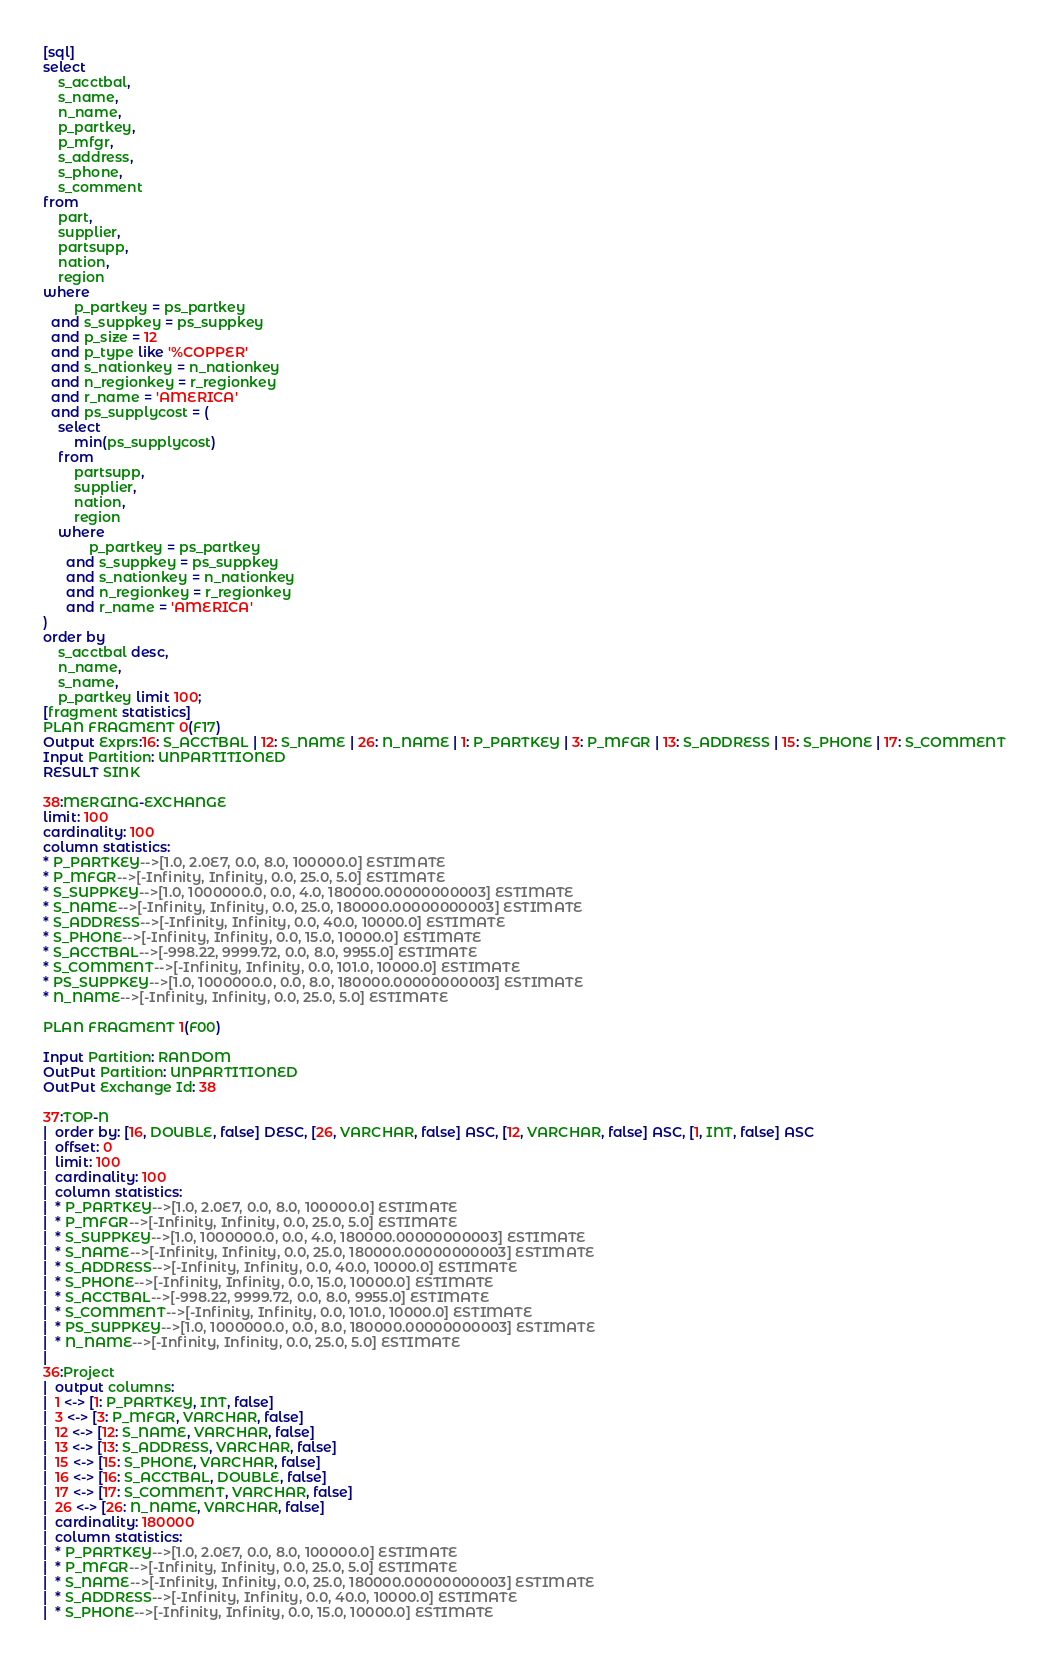Convert code to text. <code><loc_0><loc_0><loc_500><loc_500><_SQL_>[sql]
select
    s_acctbal,
    s_name,
    n_name,
    p_partkey,
    p_mfgr,
    s_address,
    s_phone,
    s_comment
from
    part,
    supplier,
    partsupp,
    nation,
    region
where
        p_partkey = ps_partkey
  and s_suppkey = ps_suppkey
  and p_size = 12
  and p_type like '%COPPER'
  and s_nationkey = n_nationkey
  and n_regionkey = r_regionkey
  and r_name = 'AMERICA'
  and ps_supplycost = (
    select
        min(ps_supplycost)
    from
        partsupp,
        supplier,
        nation,
        region
    where
            p_partkey = ps_partkey
      and s_suppkey = ps_suppkey
      and s_nationkey = n_nationkey
      and n_regionkey = r_regionkey
      and r_name = 'AMERICA'
)
order by
    s_acctbal desc,
    n_name,
    s_name,
    p_partkey limit 100;
[fragment statistics]
PLAN FRAGMENT 0(F17)
Output Exprs:16: S_ACCTBAL | 12: S_NAME | 26: N_NAME | 1: P_PARTKEY | 3: P_MFGR | 13: S_ADDRESS | 15: S_PHONE | 17: S_COMMENT
Input Partition: UNPARTITIONED
RESULT SINK

38:MERGING-EXCHANGE
limit: 100
cardinality: 100
column statistics:
* P_PARTKEY-->[1.0, 2.0E7, 0.0, 8.0, 100000.0] ESTIMATE
* P_MFGR-->[-Infinity, Infinity, 0.0, 25.0, 5.0] ESTIMATE
* S_SUPPKEY-->[1.0, 1000000.0, 0.0, 4.0, 180000.00000000003] ESTIMATE
* S_NAME-->[-Infinity, Infinity, 0.0, 25.0, 180000.00000000003] ESTIMATE
* S_ADDRESS-->[-Infinity, Infinity, 0.0, 40.0, 10000.0] ESTIMATE
* S_PHONE-->[-Infinity, Infinity, 0.0, 15.0, 10000.0] ESTIMATE
* S_ACCTBAL-->[-998.22, 9999.72, 0.0, 8.0, 9955.0] ESTIMATE
* S_COMMENT-->[-Infinity, Infinity, 0.0, 101.0, 10000.0] ESTIMATE
* PS_SUPPKEY-->[1.0, 1000000.0, 0.0, 8.0, 180000.00000000003] ESTIMATE
* N_NAME-->[-Infinity, Infinity, 0.0, 25.0, 5.0] ESTIMATE

PLAN FRAGMENT 1(F00)

Input Partition: RANDOM
OutPut Partition: UNPARTITIONED
OutPut Exchange Id: 38

37:TOP-N
|  order by: [16, DOUBLE, false] DESC, [26, VARCHAR, false] ASC, [12, VARCHAR, false] ASC, [1, INT, false] ASC
|  offset: 0
|  limit: 100
|  cardinality: 100
|  column statistics:
|  * P_PARTKEY-->[1.0, 2.0E7, 0.0, 8.0, 100000.0] ESTIMATE
|  * P_MFGR-->[-Infinity, Infinity, 0.0, 25.0, 5.0] ESTIMATE
|  * S_SUPPKEY-->[1.0, 1000000.0, 0.0, 4.0, 180000.00000000003] ESTIMATE
|  * S_NAME-->[-Infinity, Infinity, 0.0, 25.0, 180000.00000000003] ESTIMATE
|  * S_ADDRESS-->[-Infinity, Infinity, 0.0, 40.0, 10000.0] ESTIMATE
|  * S_PHONE-->[-Infinity, Infinity, 0.0, 15.0, 10000.0] ESTIMATE
|  * S_ACCTBAL-->[-998.22, 9999.72, 0.0, 8.0, 9955.0] ESTIMATE
|  * S_COMMENT-->[-Infinity, Infinity, 0.0, 101.0, 10000.0] ESTIMATE
|  * PS_SUPPKEY-->[1.0, 1000000.0, 0.0, 8.0, 180000.00000000003] ESTIMATE
|  * N_NAME-->[-Infinity, Infinity, 0.0, 25.0, 5.0] ESTIMATE
|
36:Project
|  output columns:
|  1 <-> [1: P_PARTKEY, INT, false]
|  3 <-> [3: P_MFGR, VARCHAR, false]
|  12 <-> [12: S_NAME, VARCHAR, false]
|  13 <-> [13: S_ADDRESS, VARCHAR, false]
|  15 <-> [15: S_PHONE, VARCHAR, false]
|  16 <-> [16: S_ACCTBAL, DOUBLE, false]
|  17 <-> [17: S_COMMENT, VARCHAR, false]
|  26 <-> [26: N_NAME, VARCHAR, false]
|  cardinality: 180000
|  column statistics:
|  * P_PARTKEY-->[1.0, 2.0E7, 0.0, 8.0, 100000.0] ESTIMATE
|  * P_MFGR-->[-Infinity, Infinity, 0.0, 25.0, 5.0] ESTIMATE
|  * S_NAME-->[-Infinity, Infinity, 0.0, 25.0, 180000.00000000003] ESTIMATE
|  * S_ADDRESS-->[-Infinity, Infinity, 0.0, 40.0, 10000.0] ESTIMATE
|  * S_PHONE-->[-Infinity, Infinity, 0.0, 15.0, 10000.0] ESTIMATE</code> 